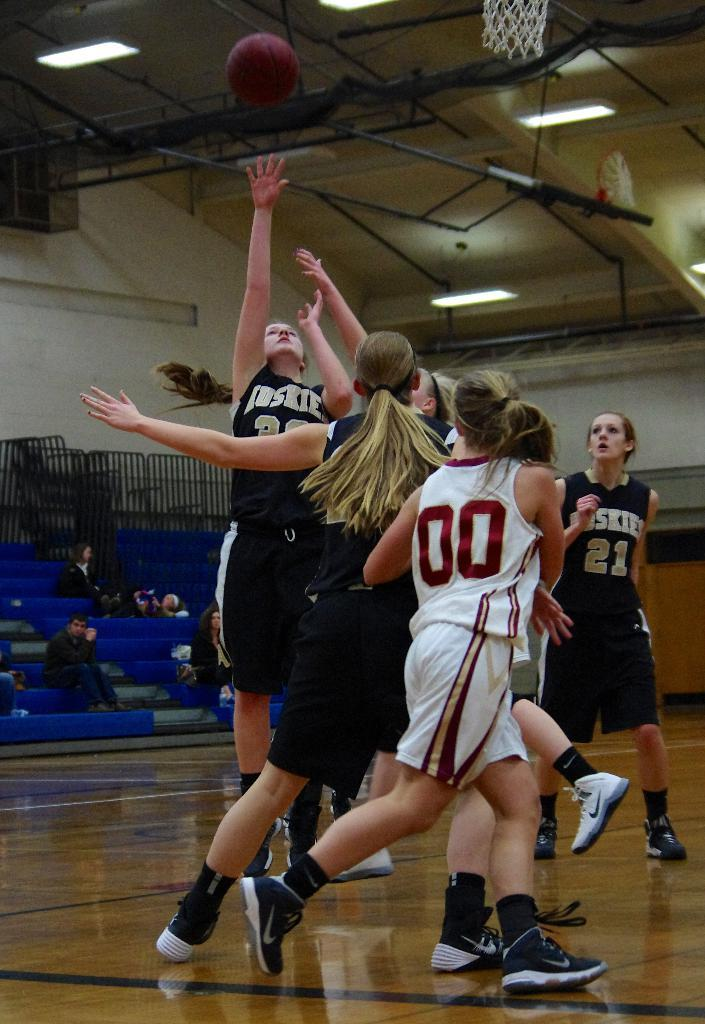<image>
Give a short and clear explanation of the subsequent image. some players that are playing basketball and has the number 00 on it 